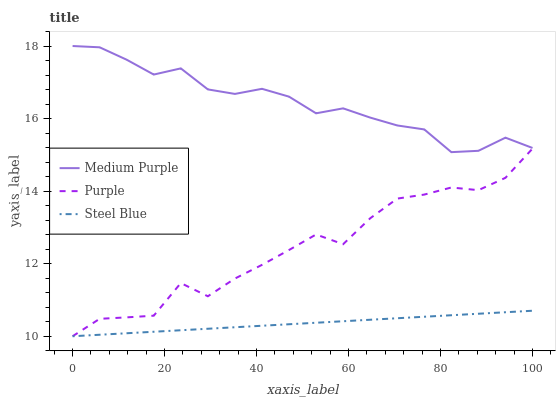Does Steel Blue have the minimum area under the curve?
Answer yes or no. Yes. Does Medium Purple have the maximum area under the curve?
Answer yes or no. Yes. Does Purple have the minimum area under the curve?
Answer yes or no. No. Does Purple have the maximum area under the curve?
Answer yes or no. No. Is Steel Blue the smoothest?
Answer yes or no. Yes. Is Purple the roughest?
Answer yes or no. Yes. Is Purple the smoothest?
Answer yes or no. No. Is Steel Blue the roughest?
Answer yes or no. No. Does Purple have the lowest value?
Answer yes or no. Yes. Does Medium Purple have the highest value?
Answer yes or no. Yes. Does Purple have the highest value?
Answer yes or no. No. Is Purple less than Medium Purple?
Answer yes or no. Yes. Is Medium Purple greater than Purple?
Answer yes or no. Yes. Does Purple intersect Steel Blue?
Answer yes or no. Yes. Is Purple less than Steel Blue?
Answer yes or no. No. Is Purple greater than Steel Blue?
Answer yes or no. No. Does Purple intersect Medium Purple?
Answer yes or no. No. 